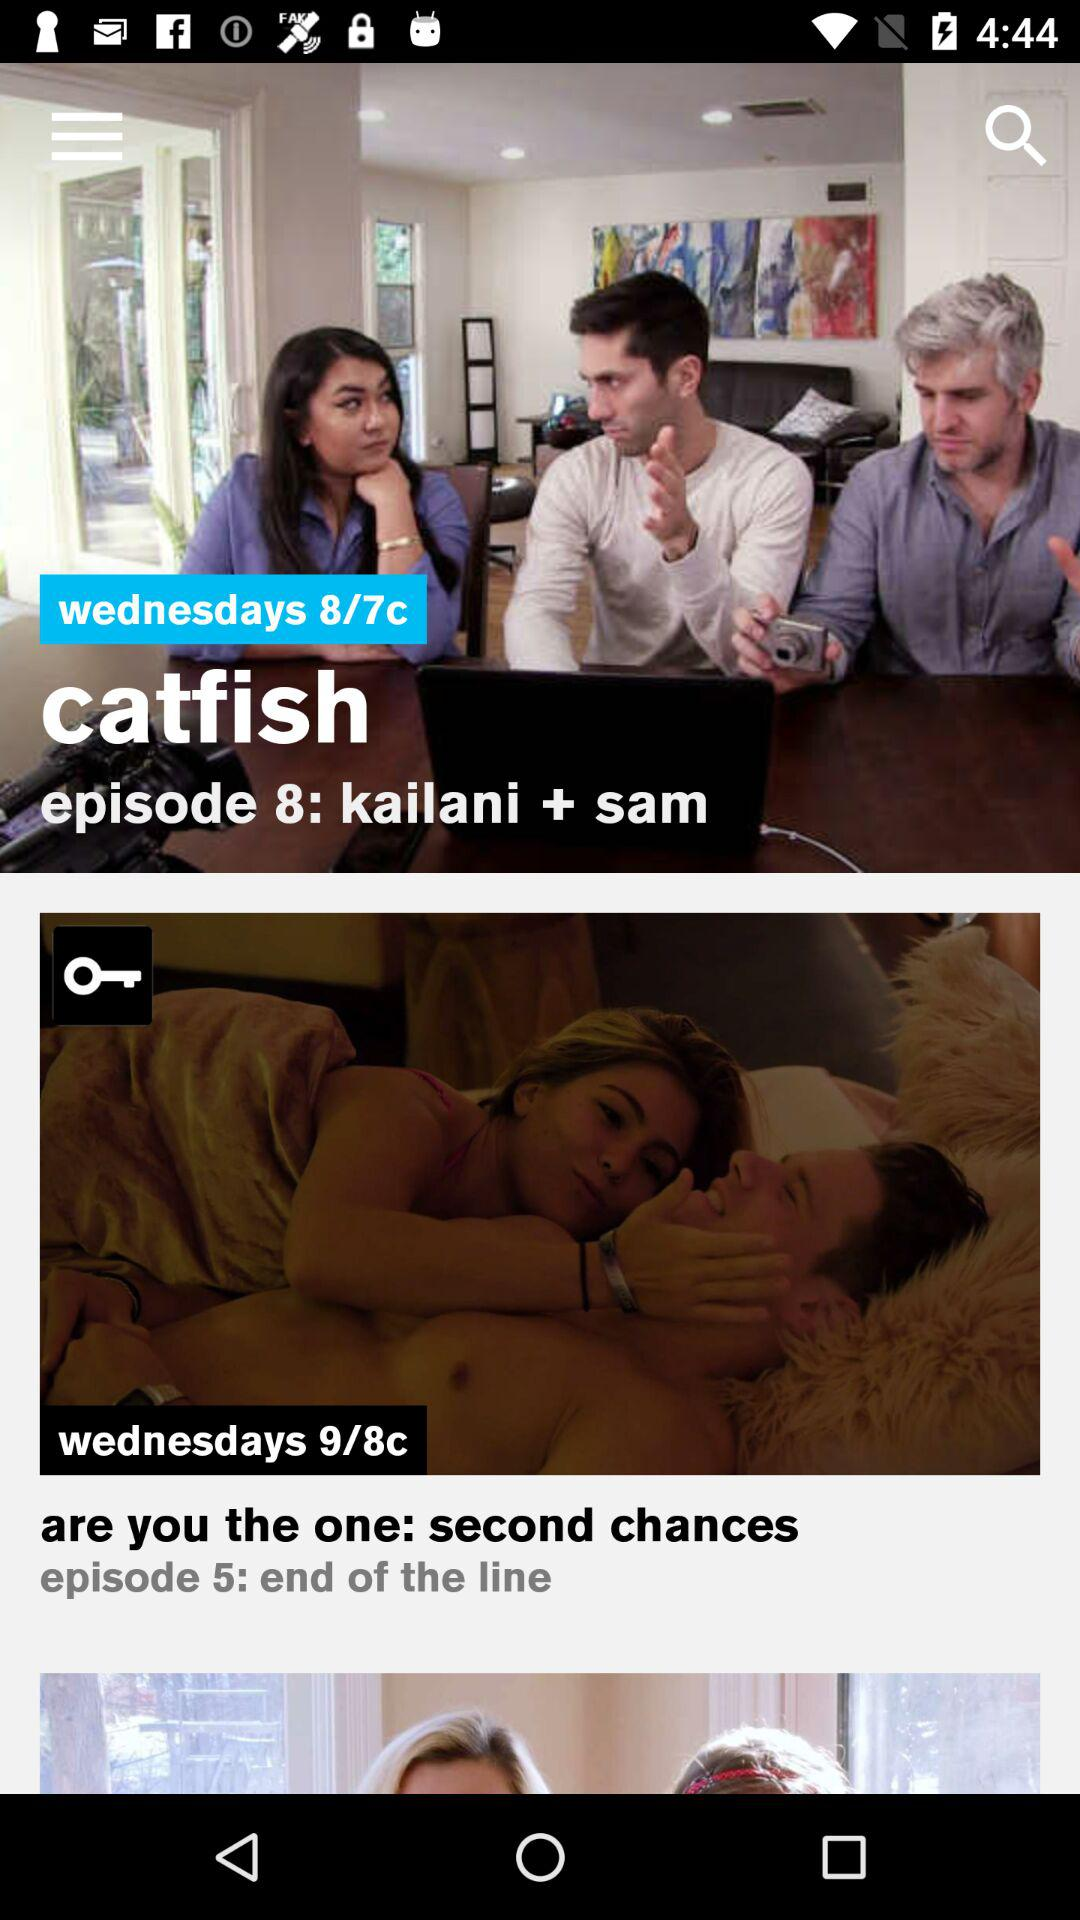How many episodes of Catfish are there?
Answer the question using a single word or phrase. 8 